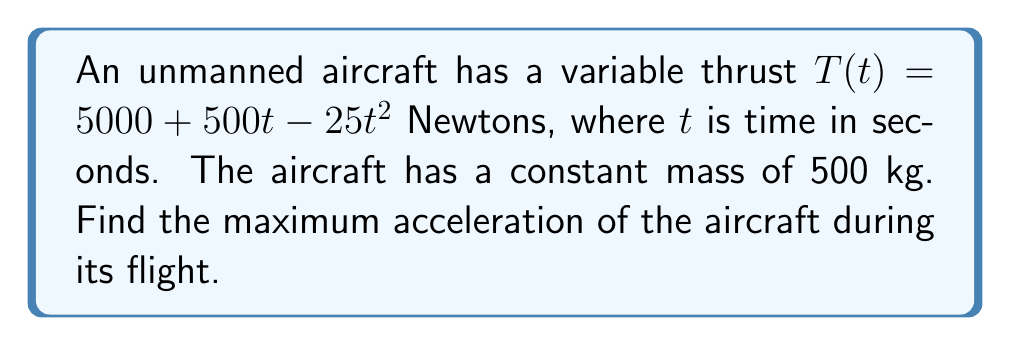Could you help me with this problem? To find the maximum acceleration, we need to follow these steps:

1) The acceleration $a(t)$ of the aircraft is given by Newton's Second Law:

   $$a(t) = \frac{F(t)}{m} = \frac{T(t)}{m}$$

   where $F(t)$ is the net force (which in this case is equal to the thrust $T(t)$), and $m$ is the mass.

2) Substituting the given thrust function and mass:

   $$a(t) = \frac{5000 + 500t - 25t^2}{500}$$

3) Simplify:

   $$a(t) = 10 + t - 0.05t^2$$

4) To find the maximum acceleration, we need to find where the derivative of $a(t)$ equals zero:

   $$\frac{d}{dt}a(t) = 1 - 0.1t$$

5) Set this equal to zero and solve for $t$:

   $$1 - 0.1t = 0$$
   $$-0.1t = -1$$
   $$t = 10$$

6) The second derivative is negative ($-0.1$), confirming this is a maximum.

7) To find the maximum acceleration, substitute $t = 10$ into the acceleration function:

   $$a(10) = 10 + 10 - 0.05(10)^2 = 20 - 5 = 15$$

Therefore, the maximum acceleration occurs at $t = 10$ seconds and has a value of 15 m/s².
Answer: 15 m/s² 